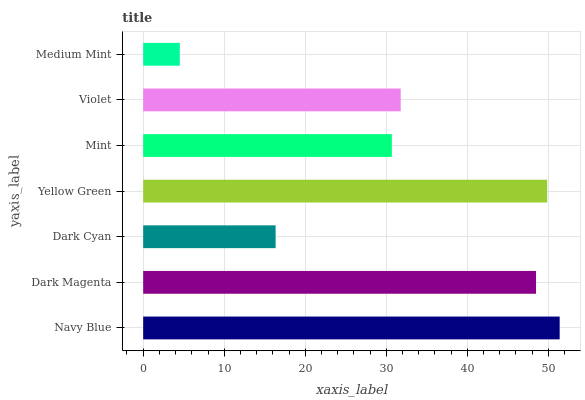Is Medium Mint the minimum?
Answer yes or no. Yes. Is Navy Blue the maximum?
Answer yes or no. Yes. Is Dark Magenta the minimum?
Answer yes or no. No. Is Dark Magenta the maximum?
Answer yes or no. No. Is Navy Blue greater than Dark Magenta?
Answer yes or no. Yes. Is Dark Magenta less than Navy Blue?
Answer yes or no. Yes. Is Dark Magenta greater than Navy Blue?
Answer yes or no. No. Is Navy Blue less than Dark Magenta?
Answer yes or no. No. Is Violet the high median?
Answer yes or no. Yes. Is Violet the low median?
Answer yes or no. Yes. Is Dark Magenta the high median?
Answer yes or no. No. Is Medium Mint the low median?
Answer yes or no. No. 